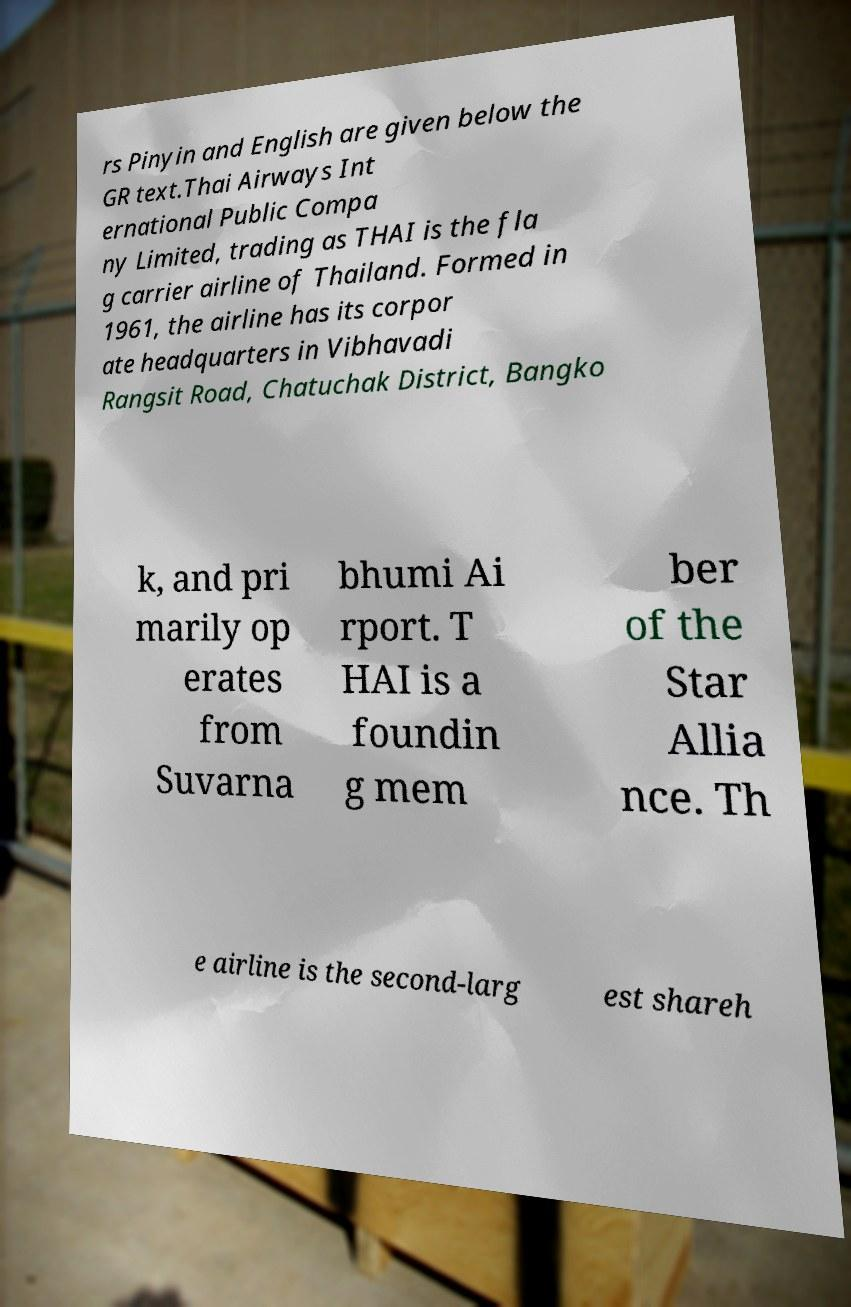Can you read and provide the text displayed in the image?This photo seems to have some interesting text. Can you extract and type it out for me? rs Pinyin and English are given below the GR text.Thai Airways Int ernational Public Compa ny Limited, trading as THAI is the fla g carrier airline of Thailand. Formed in 1961, the airline has its corpor ate headquarters in Vibhavadi Rangsit Road, Chatuchak District, Bangko k, and pri marily op erates from Suvarna bhumi Ai rport. T HAI is a foundin g mem ber of the Star Allia nce. Th e airline is the second-larg est shareh 